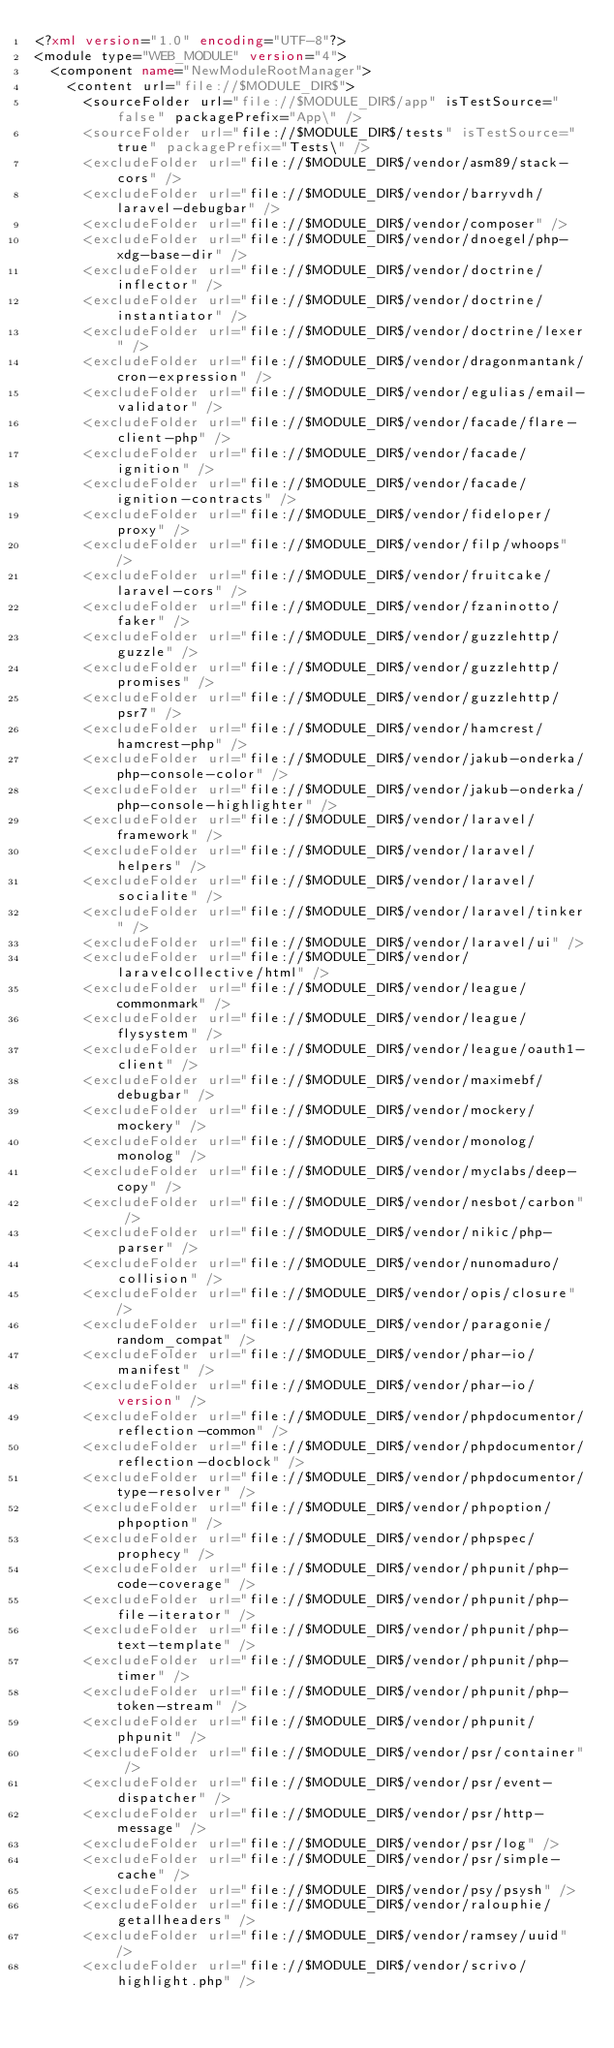Convert code to text. <code><loc_0><loc_0><loc_500><loc_500><_XML_><?xml version="1.0" encoding="UTF-8"?>
<module type="WEB_MODULE" version="4">
  <component name="NewModuleRootManager">
    <content url="file://$MODULE_DIR$">
      <sourceFolder url="file://$MODULE_DIR$/app" isTestSource="false" packagePrefix="App\" />
      <sourceFolder url="file://$MODULE_DIR$/tests" isTestSource="true" packagePrefix="Tests\" />
      <excludeFolder url="file://$MODULE_DIR$/vendor/asm89/stack-cors" />
      <excludeFolder url="file://$MODULE_DIR$/vendor/barryvdh/laravel-debugbar" />
      <excludeFolder url="file://$MODULE_DIR$/vendor/composer" />
      <excludeFolder url="file://$MODULE_DIR$/vendor/dnoegel/php-xdg-base-dir" />
      <excludeFolder url="file://$MODULE_DIR$/vendor/doctrine/inflector" />
      <excludeFolder url="file://$MODULE_DIR$/vendor/doctrine/instantiator" />
      <excludeFolder url="file://$MODULE_DIR$/vendor/doctrine/lexer" />
      <excludeFolder url="file://$MODULE_DIR$/vendor/dragonmantank/cron-expression" />
      <excludeFolder url="file://$MODULE_DIR$/vendor/egulias/email-validator" />
      <excludeFolder url="file://$MODULE_DIR$/vendor/facade/flare-client-php" />
      <excludeFolder url="file://$MODULE_DIR$/vendor/facade/ignition" />
      <excludeFolder url="file://$MODULE_DIR$/vendor/facade/ignition-contracts" />
      <excludeFolder url="file://$MODULE_DIR$/vendor/fideloper/proxy" />
      <excludeFolder url="file://$MODULE_DIR$/vendor/filp/whoops" />
      <excludeFolder url="file://$MODULE_DIR$/vendor/fruitcake/laravel-cors" />
      <excludeFolder url="file://$MODULE_DIR$/vendor/fzaninotto/faker" />
      <excludeFolder url="file://$MODULE_DIR$/vendor/guzzlehttp/guzzle" />
      <excludeFolder url="file://$MODULE_DIR$/vendor/guzzlehttp/promises" />
      <excludeFolder url="file://$MODULE_DIR$/vendor/guzzlehttp/psr7" />
      <excludeFolder url="file://$MODULE_DIR$/vendor/hamcrest/hamcrest-php" />
      <excludeFolder url="file://$MODULE_DIR$/vendor/jakub-onderka/php-console-color" />
      <excludeFolder url="file://$MODULE_DIR$/vendor/jakub-onderka/php-console-highlighter" />
      <excludeFolder url="file://$MODULE_DIR$/vendor/laravel/framework" />
      <excludeFolder url="file://$MODULE_DIR$/vendor/laravel/helpers" />
      <excludeFolder url="file://$MODULE_DIR$/vendor/laravel/socialite" />
      <excludeFolder url="file://$MODULE_DIR$/vendor/laravel/tinker" />
      <excludeFolder url="file://$MODULE_DIR$/vendor/laravel/ui" />
      <excludeFolder url="file://$MODULE_DIR$/vendor/laravelcollective/html" />
      <excludeFolder url="file://$MODULE_DIR$/vendor/league/commonmark" />
      <excludeFolder url="file://$MODULE_DIR$/vendor/league/flysystem" />
      <excludeFolder url="file://$MODULE_DIR$/vendor/league/oauth1-client" />
      <excludeFolder url="file://$MODULE_DIR$/vendor/maximebf/debugbar" />
      <excludeFolder url="file://$MODULE_DIR$/vendor/mockery/mockery" />
      <excludeFolder url="file://$MODULE_DIR$/vendor/monolog/monolog" />
      <excludeFolder url="file://$MODULE_DIR$/vendor/myclabs/deep-copy" />
      <excludeFolder url="file://$MODULE_DIR$/vendor/nesbot/carbon" />
      <excludeFolder url="file://$MODULE_DIR$/vendor/nikic/php-parser" />
      <excludeFolder url="file://$MODULE_DIR$/vendor/nunomaduro/collision" />
      <excludeFolder url="file://$MODULE_DIR$/vendor/opis/closure" />
      <excludeFolder url="file://$MODULE_DIR$/vendor/paragonie/random_compat" />
      <excludeFolder url="file://$MODULE_DIR$/vendor/phar-io/manifest" />
      <excludeFolder url="file://$MODULE_DIR$/vendor/phar-io/version" />
      <excludeFolder url="file://$MODULE_DIR$/vendor/phpdocumentor/reflection-common" />
      <excludeFolder url="file://$MODULE_DIR$/vendor/phpdocumentor/reflection-docblock" />
      <excludeFolder url="file://$MODULE_DIR$/vendor/phpdocumentor/type-resolver" />
      <excludeFolder url="file://$MODULE_DIR$/vendor/phpoption/phpoption" />
      <excludeFolder url="file://$MODULE_DIR$/vendor/phpspec/prophecy" />
      <excludeFolder url="file://$MODULE_DIR$/vendor/phpunit/php-code-coverage" />
      <excludeFolder url="file://$MODULE_DIR$/vendor/phpunit/php-file-iterator" />
      <excludeFolder url="file://$MODULE_DIR$/vendor/phpunit/php-text-template" />
      <excludeFolder url="file://$MODULE_DIR$/vendor/phpunit/php-timer" />
      <excludeFolder url="file://$MODULE_DIR$/vendor/phpunit/php-token-stream" />
      <excludeFolder url="file://$MODULE_DIR$/vendor/phpunit/phpunit" />
      <excludeFolder url="file://$MODULE_DIR$/vendor/psr/container" />
      <excludeFolder url="file://$MODULE_DIR$/vendor/psr/event-dispatcher" />
      <excludeFolder url="file://$MODULE_DIR$/vendor/psr/http-message" />
      <excludeFolder url="file://$MODULE_DIR$/vendor/psr/log" />
      <excludeFolder url="file://$MODULE_DIR$/vendor/psr/simple-cache" />
      <excludeFolder url="file://$MODULE_DIR$/vendor/psy/psysh" />
      <excludeFolder url="file://$MODULE_DIR$/vendor/ralouphie/getallheaders" />
      <excludeFolder url="file://$MODULE_DIR$/vendor/ramsey/uuid" />
      <excludeFolder url="file://$MODULE_DIR$/vendor/scrivo/highlight.php" /></code> 